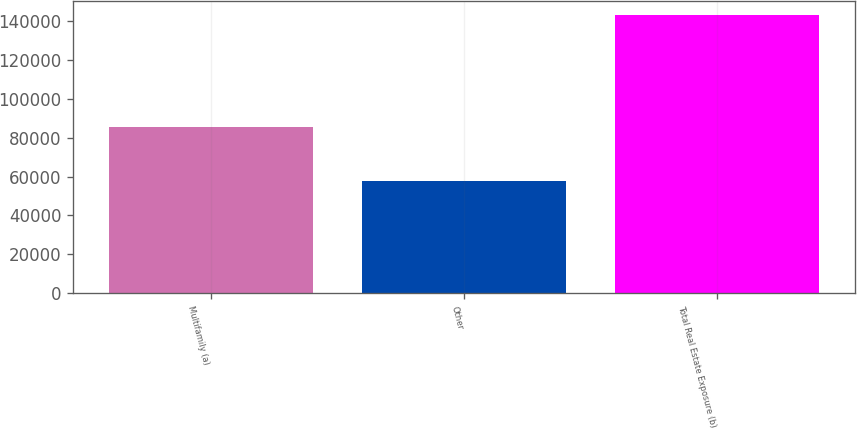Convert chart to OTSL. <chart><loc_0><loc_0><loc_500><loc_500><bar_chart><fcel>Multifamily (a)<fcel>Other<fcel>Total Real Estate Exposure (b)<nl><fcel>85716<fcel>57600<fcel>143316<nl></chart> 